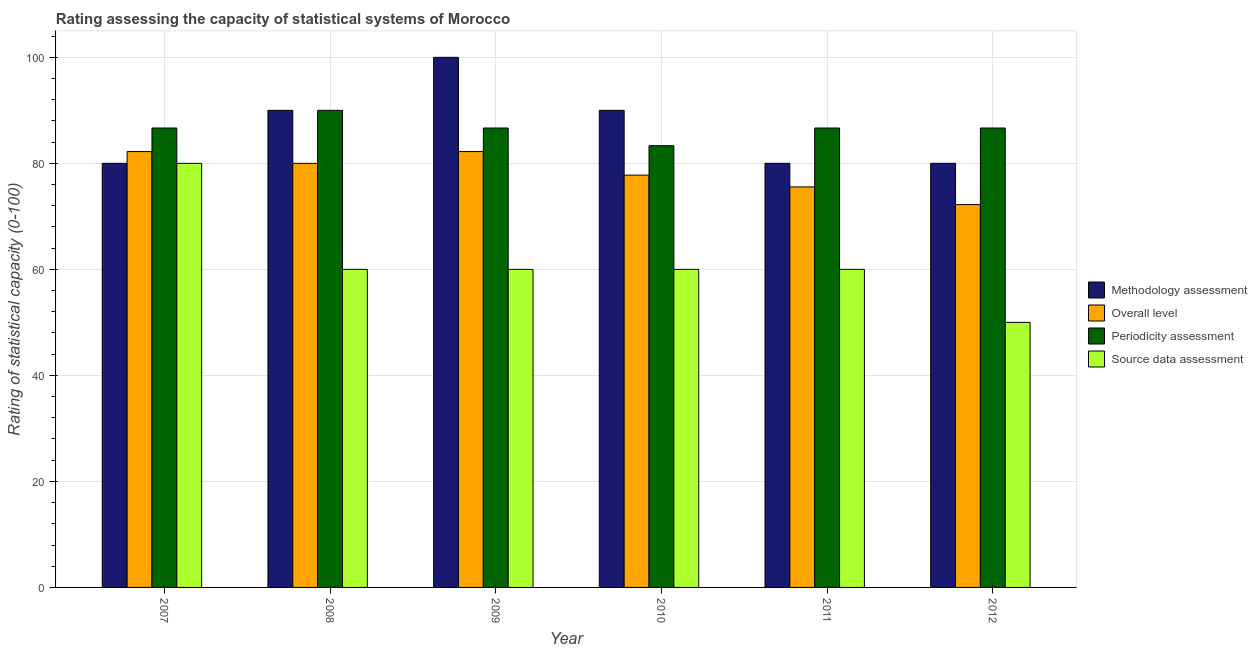How many different coloured bars are there?
Offer a terse response. 4. How many groups of bars are there?
Ensure brevity in your answer.  6. Are the number of bars per tick equal to the number of legend labels?
Provide a succinct answer. Yes. Are the number of bars on each tick of the X-axis equal?
Ensure brevity in your answer.  Yes. How many bars are there on the 1st tick from the left?
Offer a terse response. 4. How many bars are there on the 3rd tick from the right?
Your response must be concise. 4. In how many cases, is the number of bars for a given year not equal to the number of legend labels?
Offer a terse response. 0. What is the methodology assessment rating in 2008?
Give a very brief answer. 90. Across all years, what is the maximum methodology assessment rating?
Keep it short and to the point. 100. Across all years, what is the minimum methodology assessment rating?
Your answer should be compact. 80. In which year was the source data assessment rating minimum?
Offer a very short reply. 2012. What is the total overall level rating in the graph?
Your answer should be compact. 470. What is the difference between the periodicity assessment rating in 2010 and that in 2012?
Give a very brief answer. -3.33. What is the average methodology assessment rating per year?
Your answer should be very brief. 86.67. In how many years, is the source data assessment rating greater than 40?
Provide a succinct answer. 6. What is the ratio of the methodology assessment rating in 2009 to that in 2010?
Offer a very short reply. 1.11. Is the source data assessment rating in 2008 less than that in 2011?
Make the answer very short. No. What is the difference between the highest and the second highest periodicity assessment rating?
Provide a short and direct response. 3.33. In how many years, is the methodology assessment rating greater than the average methodology assessment rating taken over all years?
Offer a terse response. 3. What does the 1st bar from the left in 2010 represents?
Provide a succinct answer. Methodology assessment. What does the 1st bar from the right in 2009 represents?
Offer a very short reply. Source data assessment. How many bars are there?
Your answer should be compact. 24. Are all the bars in the graph horizontal?
Make the answer very short. No. What is the difference between two consecutive major ticks on the Y-axis?
Your response must be concise. 20. Are the values on the major ticks of Y-axis written in scientific E-notation?
Keep it short and to the point. No. Does the graph contain any zero values?
Your answer should be very brief. No. Does the graph contain grids?
Offer a terse response. Yes. Where does the legend appear in the graph?
Keep it short and to the point. Center right. How are the legend labels stacked?
Your response must be concise. Vertical. What is the title of the graph?
Provide a succinct answer. Rating assessing the capacity of statistical systems of Morocco. Does "Tracking ability" appear as one of the legend labels in the graph?
Your answer should be compact. No. What is the label or title of the Y-axis?
Your response must be concise. Rating of statistical capacity (0-100). What is the Rating of statistical capacity (0-100) in Overall level in 2007?
Ensure brevity in your answer.  82.22. What is the Rating of statistical capacity (0-100) of Periodicity assessment in 2007?
Make the answer very short. 86.67. What is the Rating of statistical capacity (0-100) of Periodicity assessment in 2008?
Provide a succinct answer. 90. What is the Rating of statistical capacity (0-100) in Source data assessment in 2008?
Make the answer very short. 60. What is the Rating of statistical capacity (0-100) in Methodology assessment in 2009?
Give a very brief answer. 100. What is the Rating of statistical capacity (0-100) in Overall level in 2009?
Your answer should be compact. 82.22. What is the Rating of statistical capacity (0-100) of Periodicity assessment in 2009?
Offer a terse response. 86.67. What is the Rating of statistical capacity (0-100) in Methodology assessment in 2010?
Offer a terse response. 90. What is the Rating of statistical capacity (0-100) of Overall level in 2010?
Your response must be concise. 77.78. What is the Rating of statistical capacity (0-100) in Periodicity assessment in 2010?
Give a very brief answer. 83.33. What is the Rating of statistical capacity (0-100) of Overall level in 2011?
Provide a short and direct response. 75.56. What is the Rating of statistical capacity (0-100) in Periodicity assessment in 2011?
Make the answer very short. 86.67. What is the Rating of statistical capacity (0-100) in Methodology assessment in 2012?
Keep it short and to the point. 80. What is the Rating of statistical capacity (0-100) of Overall level in 2012?
Your answer should be very brief. 72.22. What is the Rating of statistical capacity (0-100) of Periodicity assessment in 2012?
Provide a succinct answer. 86.67. Across all years, what is the maximum Rating of statistical capacity (0-100) of Overall level?
Your answer should be very brief. 82.22. Across all years, what is the maximum Rating of statistical capacity (0-100) in Periodicity assessment?
Ensure brevity in your answer.  90. Across all years, what is the minimum Rating of statistical capacity (0-100) of Overall level?
Ensure brevity in your answer.  72.22. Across all years, what is the minimum Rating of statistical capacity (0-100) of Periodicity assessment?
Your answer should be compact. 83.33. What is the total Rating of statistical capacity (0-100) in Methodology assessment in the graph?
Offer a terse response. 520. What is the total Rating of statistical capacity (0-100) in Overall level in the graph?
Your answer should be very brief. 470. What is the total Rating of statistical capacity (0-100) in Periodicity assessment in the graph?
Offer a terse response. 520. What is the total Rating of statistical capacity (0-100) in Source data assessment in the graph?
Offer a terse response. 370. What is the difference between the Rating of statistical capacity (0-100) in Methodology assessment in 2007 and that in 2008?
Your answer should be compact. -10. What is the difference between the Rating of statistical capacity (0-100) of Overall level in 2007 and that in 2008?
Your answer should be compact. 2.22. What is the difference between the Rating of statistical capacity (0-100) in Source data assessment in 2007 and that in 2008?
Your answer should be compact. 20. What is the difference between the Rating of statistical capacity (0-100) of Overall level in 2007 and that in 2009?
Offer a very short reply. 0. What is the difference between the Rating of statistical capacity (0-100) in Overall level in 2007 and that in 2010?
Ensure brevity in your answer.  4.44. What is the difference between the Rating of statistical capacity (0-100) of Source data assessment in 2007 and that in 2010?
Ensure brevity in your answer.  20. What is the difference between the Rating of statistical capacity (0-100) in Overall level in 2007 and that in 2011?
Your answer should be very brief. 6.67. What is the difference between the Rating of statistical capacity (0-100) in Periodicity assessment in 2007 and that in 2011?
Provide a short and direct response. 0. What is the difference between the Rating of statistical capacity (0-100) of Source data assessment in 2007 and that in 2011?
Provide a succinct answer. 20. What is the difference between the Rating of statistical capacity (0-100) in Methodology assessment in 2007 and that in 2012?
Your answer should be very brief. 0. What is the difference between the Rating of statistical capacity (0-100) in Periodicity assessment in 2007 and that in 2012?
Ensure brevity in your answer.  0. What is the difference between the Rating of statistical capacity (0-100) of Source data assessment in 2007 and that in 2012?
Make the answer very short. 30. What is the difference between the Rating of statistical capacity (0-100) in Overall level in 2008 and that in 2009?
Your response must be concise. -2.22. What is the difference between the Rating of statistical capacity (0-100) in Overall level in 2008 and that in 2010?
Offer a terse response. 2.22. What is the difference between the Rating of statistical capacity (0-100) of Periodicity assessment in 2008 and that in 2010?
Ensure brevity in your answer.  6.67. What is the difference between the Rating of statistical capacity (0-100) of Methodology assessment in 2008 and that in 2011?
Your answer should be compact. 10. What is the difference between the Rating of statistical capacity (0-100) in Overall level in 2008 and that in 2011?
Your response must be concise. 4.44. What is the difference between the Rating of statistical capacity (0-100) of Periodicity assessment in 2008 and that in 2011?
Your response must be concise. 3.33. What is the difference between the Rating of statistical capacity (0-100) of Source data assessment in 2008 and that in 2011?
Give a very brief answer. 0. What is the difference between the Rating of statistical capacity (0-100) in Overall level in 2008 and that in 2012?
Make the answer very short. 7.78. What is the difference between the Rating of statistical capacity (0-100) in Overall level in 2009 and that in 2010?
Offer a very short reply. 4.44. What is the difference between the Rating of statistical capacity (0-100) of Source data assessment in 2009 and that in 2010?
Make the answer very short. 0. What is the difference between the Rating of statistical capacity (0-100) in Periodicity assessment in 2009 and that in 2011?
Offer a terse response. 0. What is the difference between the Rating of statistical capacity (0-100) in Source data assessment in 2009 and that in 2011?
Make the answer very short. 0. What is the difference between the Rating of statistical capacity (0-100) in Overall level in 2009 and that in 2012?
Give a very brief answer. 10. What is the difference between the Rating of statistical capacity (0-100) of Methodology assessment in 2010 and that in 2011?
Your response must be concise. 10. What is the difference between the Rating of statistical capacity (0-100) of Overall level in 2010 and that in 2011?
Offer a terse response. 2.22. What is the difference between the Rating of statistical capacity (0-100) of Periodicity assessment in 2010 and that in 2011?
Offer a very short reply. -3.33. What is the difference between the Rating of statistical capacity (0-100) of Methodology assessment in 2010 and that in 2012?
Ensure brevity in your answer.  10. What is the difference between the Rating of statistical capacity (0-100) in Overall level in 2010 and that in 2012?
Offer a terse response. 5.56. What is the difference between the Rating of statistical capacity (0-100) in Periodicity assessment in 2010 and that in 2012?
Ensure brevity in your answer.  -3.33. What is the difference between the Rating of statistical capacity (0-100) of Source data assessment in 2010 and that in 2012?
Offer a very short reply. 10. What is the difference between the Rating of statistical capacity (0-100) of Source data assessment in 2011 and that in 2012?
Your response must be concise. 10. What is the difference between the Rating of statistical capacity (0-100) of Methodology assessment in 2007 and the Rating of statistical capacity (0-100) of Overall level in 2008?
Ensure brevity in your answer.  0. What is the difference between the Rating of statistical capacity (0-100) in Methodology assessment in 2007 and the Rating of statistical capacity (0-100) in Source data assessment in 2008?
Your response must be concise. 20. What is the difference between the Rating of statistical capacity (0-100) of Overall level in 2007 and the Rating of statistical capacity (0-100) of Periodicity assessment in 2008?
Give a very brief answer. -7.78. What is the difference between the Rating of statistical capacity (0-100) in Overall level in 2007 and the Rating of statistical capacity (0-100) in Source data assessment in 2008?
Provide a short and direct response. 22.22. What is the difference between the Rating of statistical capacity (0-100) of Periodicity assessment in 2007 and the Rating of statistical capacity (0-100) of Source data assessment in 2008?
Keep it short and to the point. 26.67. What is the difference between the Rating of statistical capacity (0-100) of Methodology assessment in 2007 and the Rating of statistical capacity (0-100) of Overall level in 2009?
Provide a short and direct response. -2.22. What is the difference between the Rating of statistical capacity (0-100) in Methodology assessment in 2007 and the Rating of statistical capacity (0-100) in Periodicity assessment in 2009?
Ensure brevity in your answer.  -6.67. What is the difference between the Rating of statistical capacity (0-100) of Methodology assessment in 2007 and the Rating of statistical capacity (0-100) of Source data assessment in 2009?
Provide a short and direct response. 20. What is the difference between the Rating of statistical capacity (0-100) in Overall level in 2007 and the Rating of statistical capacity (0-100) in Periodicity assessment in 2009?
Your answer should be compact. -4.44. What is the difference between the Rating of statistical capacity (0-100) of Overall level in 2007 and the Rating of statistical capacity (0-100) of Source data assessment in 2009?
Make the answer very short. 22.22. What is the difference between the Rating of statistical capacity (0-100) of Periodicity assessment in 2007 and the Rating of statistical capacity (0-100) of Source data assessment in 2009?
Your response must be concise. 26.67. What is the difference between the Rating of statistical capacity (0-100) in Methodology assessment in 2007 and the Rating of statistical capacity (0-100) in Overall level in 2010?
Ensure brevity in your answer.  2.22. What is the difference between the Rating of statistical capacity (0-100) in Methodology assessment in 2007 and the Rating of statistical capacity (0-100) in Periodicity assessment in 2010?
Your response must be concise. -3.33. What is the difference between the Rating of statistical capacity (0-100) of Methodology assessment in 2007 and the Rating of statistical capacity (0-100) of Source data assessment in 2010?
Keep it short and to the point. 20. What is the difference between the Rating of statistical capacity (0-100) of Overall level in 2007 and the Rating of statistical capacity (0-100) of Periodicity assessment in 2010?
Your answer should be compact. -1.11. What is the difference between the Rating of statistical capacity (0-100) in Overall level in 2007 and the Rating of statistical capacity (0-100) in Source data assessment in 2010?
Provide a succinct answer. 22.22. What is the difference between the Rating of statistical capacity (0-100) in Periodicity assessment in 2007 and the Rating of statistical capacity (0-100) in Source data assessment in 2010?
Offer a very short reply. 26.67. What is the difference between the Rating of statistical capacity (0-100) in Methodology assessment in 2007 and the Rating of statistical capacity (0-100) in Overall level in 2011?
Give a very brief answer. 4.44. What is the difference between the Rating of statistical capacity (0-100) of Methodology assessment in 2007 and the Rating of statistical capacity (0-100) of Periodicity assessment in 2011?
Provide a short and direct response. -6.67. What is the difference between the Rating of statistical capacity (0-100) in Methodology assessment in 2007 and the Rating of statistical capacity (0-100) in Source data assessment in 2011?
Offer a terse response. 20. What is the difference between the Rating of statistical capacity (0-100) in Overall level in 2007 and the Rating of statistical capacity (0-100) in Periodicity assessment in 2011?
Make the answer very short. -4.44. What is the difference between the Rating of statistical capacity (0-100) of Overall level in 2007 and the Rating of statistical capacity (0-100) of Source data assessment in 2011?
Offer a terse response. 22.22. What is the difference between the Rating of statistical capacity (0-100) in Periodicity assessment in 2007 and the Rating of statistical capacity (0-100) in Source data assessment in 2011?
Ensure brevity in your answer.  26.67. What is the difference between the Rating of statistical capacity (0-100) in Methodology assessment in 2007 and the Rating of statistical capacity (0-100) in Overall level in 2012?
Offer a terse response. 7.78. What is the difference between the Rating of statistical capacity (0-100) in Methodology assessment in 2007 and the Rating of statistical capacity (0-100) in Periodicity assessment in 2012?
Give a very brief answer. -6.67. What is the difference between the Rating of statistical capacity (0-100) in Methodology assessment in 2007 and the Rating of statistical capacity (0-100) in Source data assessment in 2012?
Give a very brief answer. 30. What is the difference between the Rating of statistical capacity (0-100) in Overall level in 2007 and the Rating of statistical capacity (0-100) in Periodicity assessment in 2012?
Give a very brief answer. -4.44. What is the difference between the Rating of statistical capacity (0-100) in Overall level in 2007 and the Rating of statistical capacity (0-100) in Source data assessment in 2012?
Make the answer very short. 32.22. What is the difference between the Rating of statistical capacity (0-100) of Periodicity assessment in 2007 and the Rating of statistical capacity (0-100) of Source data assessment in 2012?
Your answer should be compact. 36.67. What is the difference between the Rating of statistical capacity (0-100) in Methodology assessment in 2008 and the Rating of statistical capacity (0-100) in Overall level in 2009?
Make the answer very short. 7.78. What is the difference between the Rating of statistical capacity (0-100) in Methodology assessment in 2008 and the Rating of statistical capacity (0-100) in Source data assessment in 2009?
Make the answer very short. 30. What is the difference between the Rating of statistical capacity (0-100) in Overall level in 2008 and the Rating of statistical capacity (0-100) in Periodicity assessment in 2009?
Keep it short and to the point. -6.67. What is the difference between the Rating of statistical capacity (0-100) of Overall level in 2008 and the Rating of statistical capacity (0-100) of Source data assessment in 2009?
Make the answer very short. 20. What is the difference between the Rating of statistical capacity (0-100) in Periodicity assessment in 2008 and the Rating of statistical capacity (0-100) in Source data assessment in 2009?
Provide a short and direct response. 30. What is the difference between the Rating of statistical capacity (0-100) of Methodology assessment in 2008 and the Rating of statistical capacity (0-100) of Overall level in 2010?
Your answer should be very brief. 12.22. What is the difference between the Rating of statistical capacity (0-100) in Methodology assessment in 2008 and the Rating of statistical capacity (0-100) in Source data assessment in 2010?
Offer a terse response. 30. What is the difference between the Rating of statistical capacity (0-100) of Overall level in 2008 and the Rating of statistical capacity (0-100) of Periodicity assessment in 2010?
Provide a succinct answer. -3.33. What is the difference between the Rating of statistical capacity (0-100) of Periodicity assessment in 2008 and the Rating of statistical capacity (0-100) of Source data assessment in 2010?
Offer a very short reply. 30. What is the difference between the Rating of statistical capacity (0-100) of Methodology assessment in 2008 and the Rating of statistical capacity (0-100) of Overall level in 2011?
Make the answer very short. 14.44. What is the difference between the Rating of statistical capacity (0-100) in Methodology assessment in 2008 and the Rating of statistical capacity (0-100) in Periodicity assessment in 2011?
Offer a terse response. 3.33. What is the difference between the Rating of statistical capacity (0-100) in Methodology assessment in 2008 and the Rating of statistical capacity (0-100) in Source data assessment in 2011?
Ensure brevity in your answer.  30. What is the difference between the Rating of statistical capacity (0-100) of Overall level in 2008 and the Rating of statistical capacity (0-100) of Periodicity assessment in 2011?
Offer a very short reply. -6.67. What is the difference between the Rating of statistical capacity (0-100) in Overall level in 2008 and the Rating of statistical capacity (0-100) in Source data assessment in 2011?
Give a very brief answer. 20. What is the difference between the Rating of statistical capacity (0-100) of Periodicity assessment in 2008 and the Rating of statistical capacity (0-100) of Source data assessment in 2011?
Offer a very short reply. 30. What is the difference between the Rating of statistical capacity (0-100) of Methodology assessment in 2008 and the Rating of statistical capacity (0-100) of Overall level in 2012?
Provide a succinct answer. 17.78. What is the difference between the Rating of statistical capacity (0-100) of Methodology assessment in 2008 and the Rating of statistical capacity (0-100) of Periodicity assessment in 2012?
Offer a very short reply. 3.33. What is the difference between the Rating of statistical capacity (0-100) in Overall level in 2008 and the Rating of statistical capacity (0-100) in Periodicity assessment in 2012?
Make the answer very short. -6.67. What is the difference between the Rating of statistical capacity (0-100) in Overall level in 2008 and the Rating of statistical capacity (0-100) in Source data assessment in 2012?
Provide a succinct answer. 30. What is the difference between the Rating of statistical capacity (0-100) in Methodology assessment in 2009 and the Rating of statistical capacity (0-100) in Overall level in 2010?
Ensure brevity in your answer.  22.22. What is the difference between the Rating of statistical capacity (0-100) of Methodology assessment in 2009 and the Rating of statistical capacity (0-100) of Periodicity assessment in 2010?
Offer a terse response. 16.67. What is the difference between the Rating of statistical capacity (0-100) in Overall level in 2009 and the Rating of statistical capacity (0-100) in Periodicity assessment in 2010?
Provide a short and direct response. -1.11. What is the difference between the Rating of statistical capacity (0-100) of Overall level in 2009 and the Rating of statistical capacity (0-100) of Source data assessment in 2010?
Offer a very short reply. 22.22. What is the difference between the Rating of statistical capacity (0-100) of Periodicity assessment in 2009 and the Rating of statistical capacity (0-100) of Source data assessment in 2010?
Make the answer very short. 26.67. What is the difference between the Rating of statistical capacity (0-100) in Methodology assessment in 2009 and the Rating of statistical capacity (0-100) in Overall level in 2011?
Offer a very short reply. 24.44. What is the difference between the Rating of statistical capacity (0-100) in Methodology assessment in 2009 and the Rating of statistical capacity (0-100) in Periodicity assessment in 2011?
Give a very brief answer. 13.33. What is the difference between the Rating of statistical capacity (0-100) of Methodology assessment in 2009 and the Rating of statistical capacity (0-100) of Source data assessment in 2011?
Offer a terse response. 40. What is the difference between the Rating of statistical capacity (0-100) of Overall level in 2009 and the Rating of statistical capacity (0-100) of Periodicity assessment in 2011?
Provide a succinct answer. -4.44. What is the difference between the Rating of statistical capacity (0-100) of Overall level in 2009 and the Rating of statistical capacity (0-100) of Source data assessment in 2011?
Your response must be concise. 22.22. What is the difference between the Rating of statistical capacity (0-100) in Periodicity assessment in 2009 and the Rating of statistical capacity (0-100) in Source data assessment in 2011?
Your answer should be very brief. 26.67. What is the difference between the Rating of statistical capacity (0-100) in Methodology assessment in 2009 and the Rating of statistical capacity (0-100) in Overall level in 2012?
Provide a short and direct response. 27.78. What is the difference between the Rating of statistical capacity (0-100) in Methodology assessment in 2009 and the Rating of statistical capacity (0-100) in Periodicity assessment in 2012?
Give a very brief answer. 13.33. What is the difference between the Rating of statistical capacity (0-100) in Methodology assessment in 2009 and the Rating of statistical capacity (0-100) in Source data assessment in 2012?
Offer a very short reply. 50. What is the difference between the Rating of statistical capacity (0-100) in Overall level in 2009 and the Rating of statistical capacity (0-100) in Periodicity assessment in 2012?
Keep it short and to the point. -4.44. What is the difference between the Rating of statistical capacity (0-100) of Overall level in 2009 and the Rating of statistical capacity (0-100) of Source data assessment in 2012?
Your answer should be compact. 32.22. What is the difference between the Rating of statistical capacity (0-100) of Periodicity assessment in 2009 and the Rating of statistical capacity (0-100) of Source data assessment in 2012?
Your answer should be very brief. 36.67. What is the difference between the Rating of statistical capacity (0-100) in Methodology assessment in 2010 and the Rating of statistical capacity (0-100) in Overall level in 2011?
Give a very brief answer. 14.44. What is the difference between the Rating of statistical capacity (0-100) in Methodology assessment in 2010 and the Rating of statistical capacity (0-100) in Periodicity assessment in 2011?
Your response must be concise. 3.33. What is the difference between the Rating of statistical capacity (0-100) in Overall level in 2010 and the Rating of statistical capacity (0-100) in Periodicity assessment in 2011?
Provide a succinct answer. -8.89. What is the difference between the Rating of statistical capacity (0-100) in Overall level in 2010 and the Rating of statistical capacity (0-100) in Source data assessment in 2011?
Keep it short and to the point. 17.78. What is the difference between the Rating of statistical capacity (0-100) in Periodicity assessment in 2010 and the Rating of statistical capacity (0-100) in Source data assessment in 2011?
Provide a short and direct response. 23.33. What is the difference between the Rating of statistical capacity (0-100) of Methodology assessment in 2010 and the Rating of statistical capacity (0-100) of Overall level in 2012?
Provide a short and direct response. 17.78. What is the difference between the Rating of statistical capacity (0-100) in Methodology assessment in 2010 and the Rating of statistical capacity (0-100) in Source data assessment in 2012?
Your answer should be compact. 40. What is the difference between the Rating of statistical capacity (0-100) of Overall level in 2010 and the Rating of statistical capacity (0-100) of Periodicity assessment in 2012?
Make the answer very short. -8.89. What is the difference between the Rating of statistical capacity (0-100) of Overall level in 2010 and the Rating of statistical capacity (0-100) of Source data assessment in 2012?
Your response must be concise. 27.78. What is the difference between the Rating of statistical capacity (0-100) in Periodicity assessment in 2010 and the Rating of statistical capacity (0-100) in Source data assessment in 2012?
Your response must be concise. 33.33. What is the difference between the Rating of statistical capacity (0-100) in Methodology assessment in 2011 and the Rating of statistical capacity (0-100) in Overall level in 2012?
Ensure brevity in your answer.  7.78. What is the difference between the Rating of statistical capacity (0-100) in Methodology assessment in 2011 and the Rating of statistical capacity (0-100) in Periodicity assessment in 2012?
Your answer should be very brief. -6.67. What is the difference between the Rating of statistical capacity (0-100) of Overall level in 2011 and the Rating of statistical capacity (0-100) of Periodicity assessment in 2012?
Make the answer very short. -11.11. What is the difference between the Rating of statistical capacity (0-100) in Overall level in 2011 and the Rating of statistical capacity (0-100) in Source data assessment in 2012?
Offer a terse response. 25.56. What is the difference between the Rating of statistical capacity (0-100) of Periodicity assessment in 2011 and the Rating of statistical capacity (0-100) of Source data assessment in 2012?
Your answer should be very brief. 36.67. What is the average Rating of statistical capacity (0-100) of Methodology assessment per year?
Give a very brief answer. 86.67. What is the average Rating of statistical capacity (0-100) in Overall level per year?
Offer a terse response. 78.33. What is the average Rating of statistical capacity (0-100) of Periodicity assessment per year?
Your answer should be compact. 86.67. What is the average Rating of statistical capacity (0-100) in Source data assessment per year?
Your response must be concise. 61.67. In the year 2007, what is the difference between the Rating of statistical capacity (0-100) in Methodology assessment and Rating of statistical capacity (0-100) in Overall level?
Give a very brief answer. -2.22. In the year 2007, what is the difference between the Rating of statistical capacity (0-100) of Methodology assessment and Rating of statistical capacity (0-100) of Periodicity assessment?
Provide a short and direct response. -6.67. In the year 2007, what is the difference between the Rating of statistical capacity (0-100) in Overall level and Rating of statistical capacity (0-100) in Periodicity assessment?
Provide a succinct answer. -4.44. In the year 2007, what is the difference between the Rating of statistical capacity (0-100) in Overall level and Rating of statistical capacity (0-100) in Source data assessment?
Offer a terse response. 2.22. In the year 2008, what is the difference between the Rating of statistical capacity (0-100) of Methodology assessment and Rating of statistical capacity (0-100) of Overall level?
Ensure brevity in your answer.  10. In the year 2008, what is the difference between the Rating of statistical capacity (0-100) of Methodology assessment and Rating of statistical capacity (0-100) of Source data assessment?
Provide a succinct answer. 30. In the year 2008, what is the difference between the Rating of statistical capacity (0-100) of Overall level and Rating of statistical capacity (0-100) of Periodicity assessment?
Keep it short and to the point. -10. In the year 2008, what is the difference between the Rating of statistical capacity (0-100) of Overall level and Rating of statistical capacity (0-100) of Source data assessment?
Offer a very short reply. 20. In the year 2009, what is the difference between the Rating of statistical capacity (0-100) of Methodology assessment and Rating of statistical capacity (0-100) of Overall level?
Ensure brevity in your answer.  17.78. In the year 2009, what is the difference between the Rating of statistical capacity (0-100) of Methodology assessment and Rating of statistical capacity (0-100) of Periodicity assessment?
Provide a short and direct response. 13.33. In the year 2009, what is the difference between the Rating of statistical capacity (0-100) in Overall level and Rating of statistical capacity (0-100) in Periodicity assessment?
Provide a succinct answer. -4.44. In the year 2009, what is the difference between the Rating of statistical capacity (0-100) in Overall level and Rating of statistical capacity (0-100) in Source data assessment?
Make the answer very short. 22.22. In the year 2009, what is the difference between the Rating of statistical capacity (0-100) of Periodicity assessment and Rating of statistical capacity (0-100) of Source data assessment?
Offer a very short reply. 26.67. In the year 2010, what is the difference between the Rating of statistical capacity (0-100) of Methodology assessment and Rating of statistical capacity (0-100) of Overall level?
Your answer should be compact. 12.22. In the year 2010, what is the difference between the Rating of statistical capacity (0-100) of Overall level and Rating of statistical capacity (0-100) of Periodicity assessment?
Make the answer very short. -5.56. In the year 2010, what is the difference between the Rating of statistical capacity (0-100) in Overall level and Rating of statistical capacity (0-100) in Source data assessment?
Your answer should be very brief. 17.78. In the year 2010, what is the difference between the Rating of statistical capacity (0-100) of Periodicity assessment and Rating of statistical capacity (0-100) of Source data assessment?
Your answer should be very brief. 23.33. In the year 2011, what is the difference between the Rating of statistical capacity (0-100) in Methodology assessment and Rating of statistical capacity (0-100) in Overall level?
Offer a very short reply. 4.44. In the year 2011, what is the difference between the Rating of statistical capacity (0-100) of Methodology assessment and Rating of statistical capacity (0-100) of Periodicity assessment?
Give a very brief answer. -6.67. In the year 2011, what is the difference between the Rating of statistical capacity (0-100) in Overall level and Rating of statistical capacity (0-100) in Periodicity assessment?
Keep it short and to the point. -11.11. In the year 2011, what is the difference between the Rating of statistical capacity (0-100) in Overall level and Rating of statistical capacity (0-100) in Source data assessment?
Provide a short and direct response. 15.56. In the year 2011, what is the difference between the Rating of statistical capacity (0-100) of Periodicity assessment and Rating of statistical capacity (0-100) of Source data assessment?
Give a very brief answer. 26.67. In the year 2012, what is the difference between the Rating of statistical capacity (0-100) in Methodology assessment and Rating of statistical capacity (0-100) in Overall level?
Offer a very short reply. 7.78. In the year 2012, what is the difference between the Rating of statistical capacity (0-100) in Methodology assessment and Rating of statistical capacity (0-100) in Periodicity assessment?
Offer a terse response. -6.67. In the year 2012, what is the difference between the Rating of statistical capacity (0-100) of Methodology assessment and Rating of statistical capacity (0-100) of Source data assessment?
Ensure brevity in your answer.  30. In the year 2012, what is the difference between the Rating of statistical capacity (0-100) of Overall level and Rating of statistical capacity (0-100) of Periodicity assessment?
Ensure brevity in your answer.  -14.44. In the year 2012, what is the difference between the Rating of statistical capacity (0-100) of Overall level and Rating of statistical capacity (0-100) of Source data assessment?
Offer a very short reply. 22.22. In the year 2012, what is the difference between the Rating of statistical capacity (0-100) of Periodicity assessment and Rating of statistical capacity (0-100) of Source data assessment?
Your answer should be very brief. 36.67. What is the ratio of the Rating of statistical capacity (0-100) of Methodology assessment in 2007 to that in 2008?
Your answer should be compact. 0.89. What is the ratio of the Rating of statistical capacity (0-100) in Overall level in 2007 to that in 2008?
Your answer should be compact. 1.03. What is the ratio of the Rating of statistical capacity (0-100) in Source data assessment in 2007 to that in 2008?
Offer a very short reply. 1.33. What is the ratio of the Rating of statistical capacity (0-100) in Methodology assessment in 2007 to that in 2009?
Your response must be concise. 0.8. What is the ratio of the Rating of statistical capacity (0-100) of Overall level in 2007 to that in 2009?
Make the answer very short. 1. What is the ratio of the Rating of statistical capacity (0-100) of Source data assessment in 2007 to that in 2009?
Give a very brief answer. 1.33. What is the ratio of the Rating of statistical capacity (0-100) of Overall level in 2007 to that in 2010?
Ensure brevity in your answer.  1.06. What is the ratio of the Rating of statistical capacity (0-100) of Overall level in 2007 to that in 2011?
Give a very brief answer. 1.09. What is the ratio of the Rating of statistical capacity (0-100) in Overall level in 2007 to that in 2012?
Your answer should be very brief. 1.14. What is the ratio of the Rating of statistical capacity (0-100) in Source data assessment in 2007 to that in 2012?
Keep it short and to the point. 1.6. What is the ratio of the Rating of statistical capacity (0-100) in Methodology assessment in 2008 to that in 2009?
Offer a terse response. 0.9. What is the ratio of the Rating of statistical capacity (0-100) of Periodicity assessment in 2008 to that in 2009?
Give a very brief answer. 1.04. What is the ratio of the Rating of statistical capacity (0-100) of Source data assessment in 2008 to that in 2009?
Ensure brevity in your answer.  1. What is the ratio of the Rating of statistical capacity (0-100) of Methodology assessment in 2008 to that in 2010?
Make the answer very short. 1. What is the ratio of the Rating of statistical capacity (0-100) of Overall level in 2008 to that in 2010?
Provide a short and direct response. 1.03. What is the ratio of the Rating of statistical capacity (0-100) of Methodology assessment in 2008 to that in 2011?
Your response must be concise. 1.12. What is the ratio of the Rating of statistical capacity (0-100) in Overall level in 2008 to that in 2011?
Keep it short and to the point. 1.06. What is the ratio of the Rating of statistical capacity (0-100) in Periodicity assessment in 2008 to that in 2011?
Keep it short and to the point. 1.04. What is the ratio of the Rating of statistical capacity (0-100) of Methodology assessment in 2008 to that in 2012?
Your answer should be very brief. 1.12. What is the ratio of the Rating of statistical capacity (0-100) in Overall level in 2008 to that in 2012?
Give a very brief answer. 1.11. What is the ratio of the Rating of statistical capacity (0-100) of Periodicity assessment in 2008 to that in 2012?
Make the answer very short. 1.04. What is the ratio of the Rating of statistical capacity (0-100) of Overall level in 2009 to that in 2010?
Provide a short and direct response. 1.06. What is the ratio of the Rating of statistical capacity (0-100) of Periodicity assessment in 2009 to that in 2010?
Offer a very short reply. 1.04. What is the ratio of the Rating of statistical capacity (0-100) of Source data assessment in 2009 to that in 2010?
Offer a terse response. 1. What is the ratio of the Rating of statistical capacity (0-100) in Methodology assessment in 2009 to that in 2011?
Ensure brevity in your answer.  1.25. What is the ratio of the Rating of statistical capacity (0-100) in Overall level in 2009 to that in 2011?
Your response must be concise. 1.09. What is the ratio of the Rating of statistical capacity (0-100) in Periodicity assessment in 2009 to that in 2011?
Provide a succinct answer. 1. What is the ratio of the Rating of statistical capacity (0-100) of Methodology assessment in 2009 to that in 2012?
Offer a very short reply. 1.25. What is the ratio of the Rating of statistical capacity (0-100) of Overall level in 2009 to that in 2012?
Provide a succinct answer. 1.14. What is the ratio of the Rating of statistical capacity (0-100) of Periodicity assessment in 2009 to that in 2012?
Provide a short and direct response. 1. What is the ratio of the Rating of statistical capacity (0-100) of Methodology assessment in 2010 to that in 2011?
Provide a short and direct response. 1.12. What is the ratio of the Rating of statistical capacity (0-100) of Overall level in 2010 to that in 2011?
Your response must be concise. 1.03. What is the ratio of the Rating of statistical capacity (0-100) in Periodicity assessment in 2010 to that in 2011?
Make the answer very short. 0.96. What is the ratio of the Rating of statistical capacity (0-100) of Overall level in 2010 to that in 2012?
Ensure brevity in your answer.  1.08. What is the ratio of the Rating of statistical capacity (0-100) of Periodicity assessment in 2010 to that in 2012?
Provide a short and direct response. 0.96. What is the ratio of the Rating of statistical capacity (0-100) in Source data assessment in 2010 to that in 2012?
Make the answer very short. 1.2. What is the ratio of the Rating of statistical capacity (0-100) of Overall level in 2011 to that in 2012?
Offer a very short reply. 1.05. What is the difference between the highest and the second highest Rating of statistical capacity (0-100) in Source data assessment?
Give a very brief answer. 20. What is the difference between the highest and the lowest Rating of statistical capacity (0-100) in Source data assessment?
Offer a very short reply. 30. 